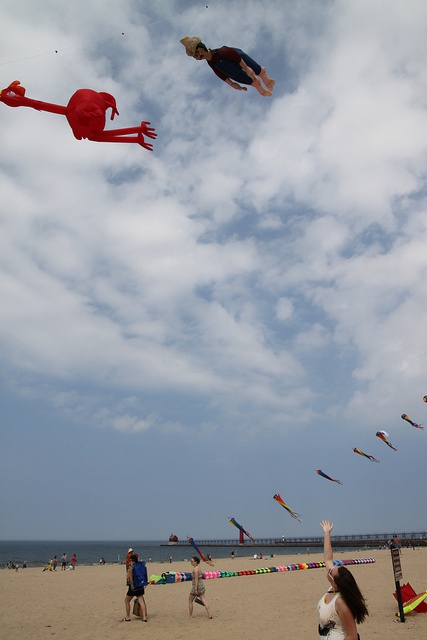Describe the objects in this image and their specific colors. I can see kite in lightgray, maroon, darkgray, and brown tones, people in lightgray, black, gray, and darkgray tones, kite in lightgray, black, maroon, brown, and gray tones, people in lightgray, black, navy, gray, and maroon tones, and people in lightgray, gray, maroon, and tan tones in this image. 